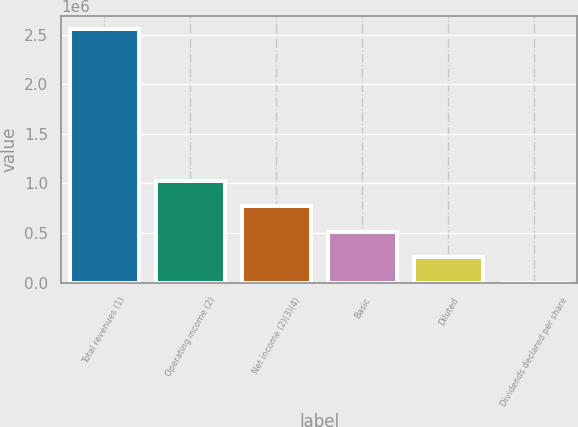<chart> <loc_0><loc_0><loc_500><loc_500><bar_chart><fcel>Total revenues (1)<fcel>Operating income (2)<fcel>Net income (2)(3)(4)<fcel>Basic<fcel>Diluted<fcel>Dividends declared per share<nl><fcel>2.56374e+06<fcel>1.0255e+06<fcel>769123<fcel>512749<fcel>256375<fcel>0.48<nl></chart> 